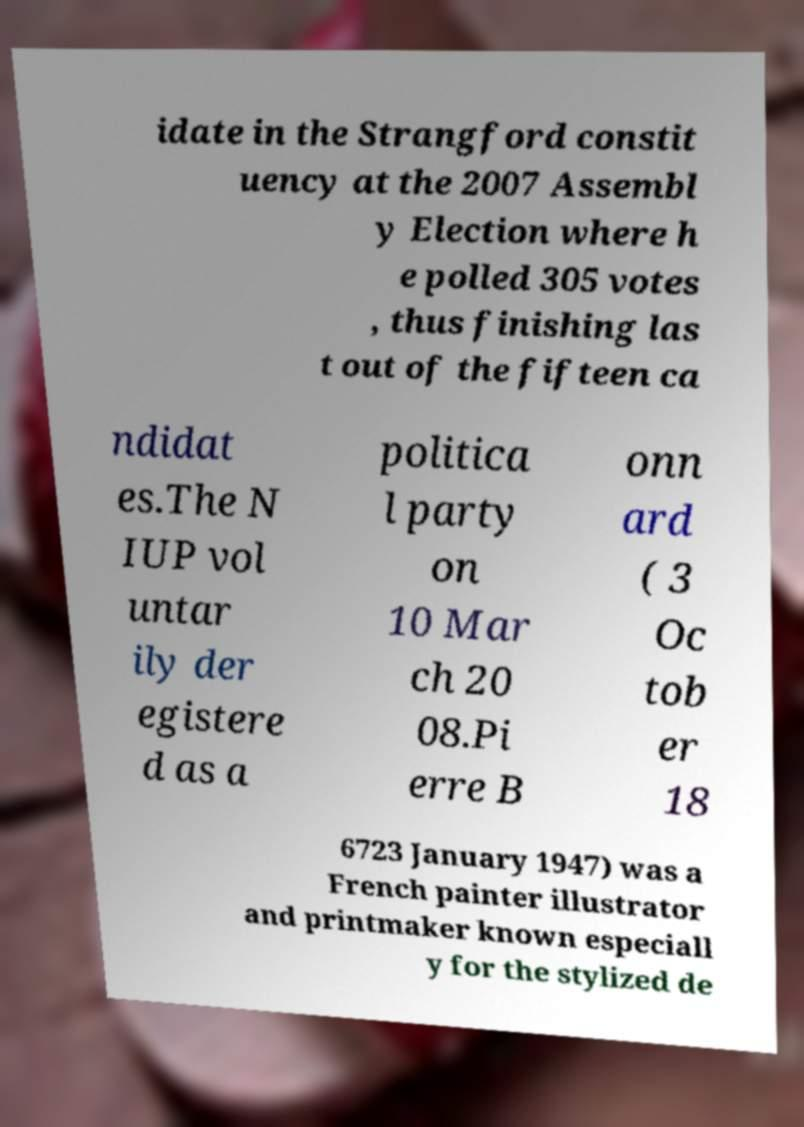Please read and relay the text visible in this image. What does it say? idate in the Strangford constit uency at the 2007 Assembl y Election where h e polled 305 votes , thus finishing las t out of the fifteen ca ndidat es.The N IUP vol untar ily der egistere d as a politica l party on 10 Mar ch 20 08.Pi erre B onn ard ( 3 Oc tob er 18 6723 January 1947) was a French painter illustrator and printmaker known especiall y for the stylized de 